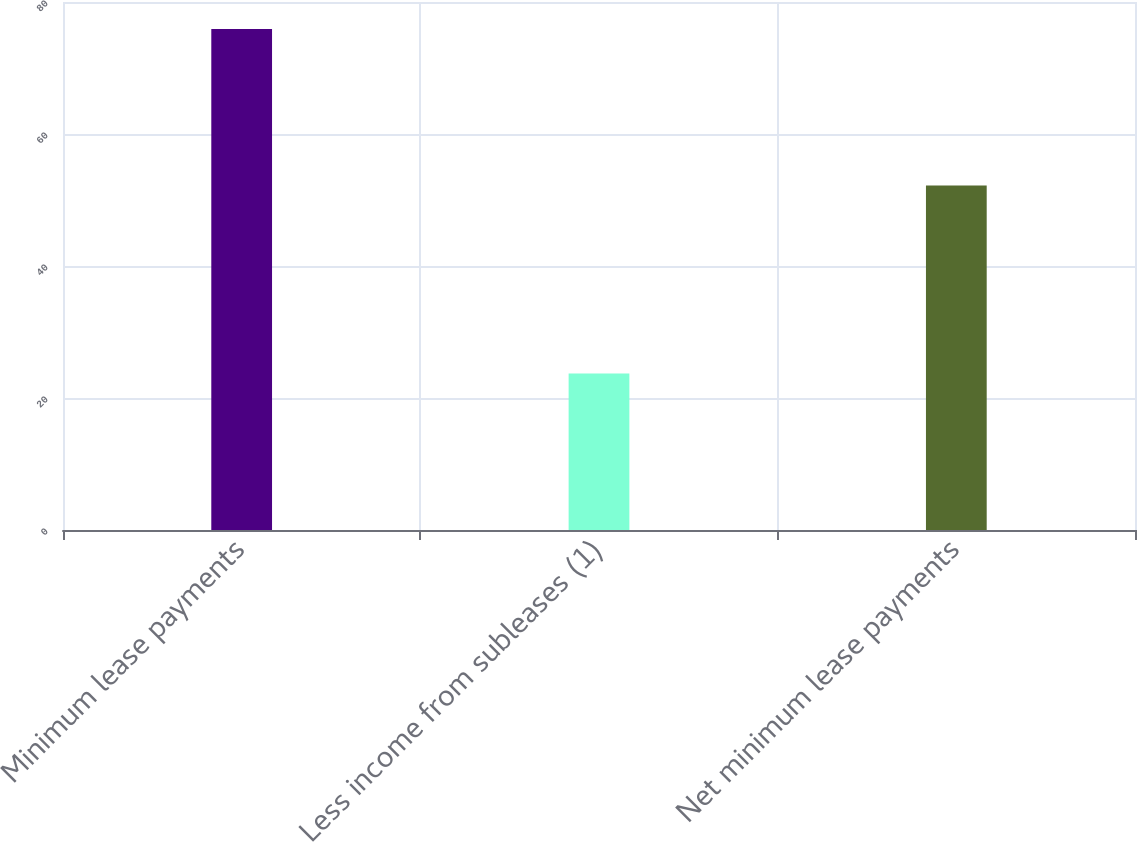<chart> <loc_0><loc_0><loc_500><loc_500><bar_chart><fcel>Minimum lease payments<fcel>Less income from subleases (1)<fcel>Net minimum lease payments<nl><fcel>75.9<fcel>23.7<fcel>52.2<nl></chart> 